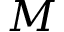<formula> <loc_0><loc_0><loc_500><loc_500>M</formula> 